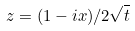<formula> <loc_0><loc_0><loc_500><loc_500>z = ( 1 - i x ) / 2 \sqrt { t }</formula> 